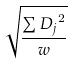<formula> <loc_0><loc_0><loc_500><loc_500>\sqrt { \frac { \sum { D _ { j } } ^ { 2 } } { w } }</formula> 